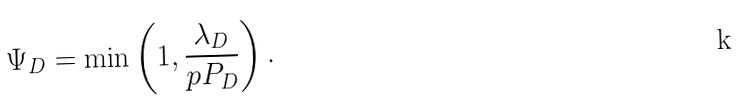Convert formula to latex. <formula><loc_0><loc_0><loc_500><loc_500>\Psi _ { D } = \min \left ( 1 , \frac { \lambda _ { D } } { p P _ { D } } \right ) .</formula> 